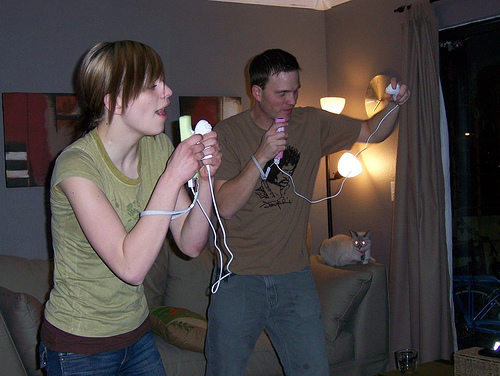<image>What time does the clock read? I don't know what time the clock read. Which woman is looking at her phone? It is ambiguous which woman is looking at her phone, as it could be the one on the left, or it could be none of them. What time does the clock read? There is no clock in the image. Which woman is looking at her phone? I don't know which woman is looking at her phone. It is not clear from the given information. 